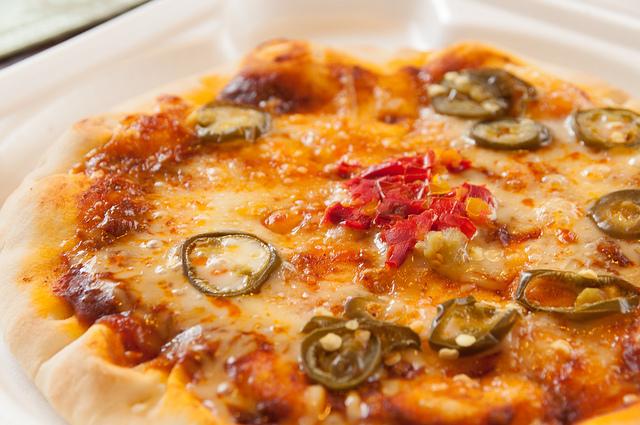What is the green stuff on the pizza?
Concise answer only. Jalapenos. What topping is most prominent on the pizza shown?
Answer briefly. Cheese. Is this pizza perfectly round?
Give a very brief answer. Yes. What food is this?
Keep it brief. Pizza. Is there cheese on the pizza?
Give a very brief answer. Yes. What is the name of the green vegetable in this food?
Write a very short answer. Jalapeno. 